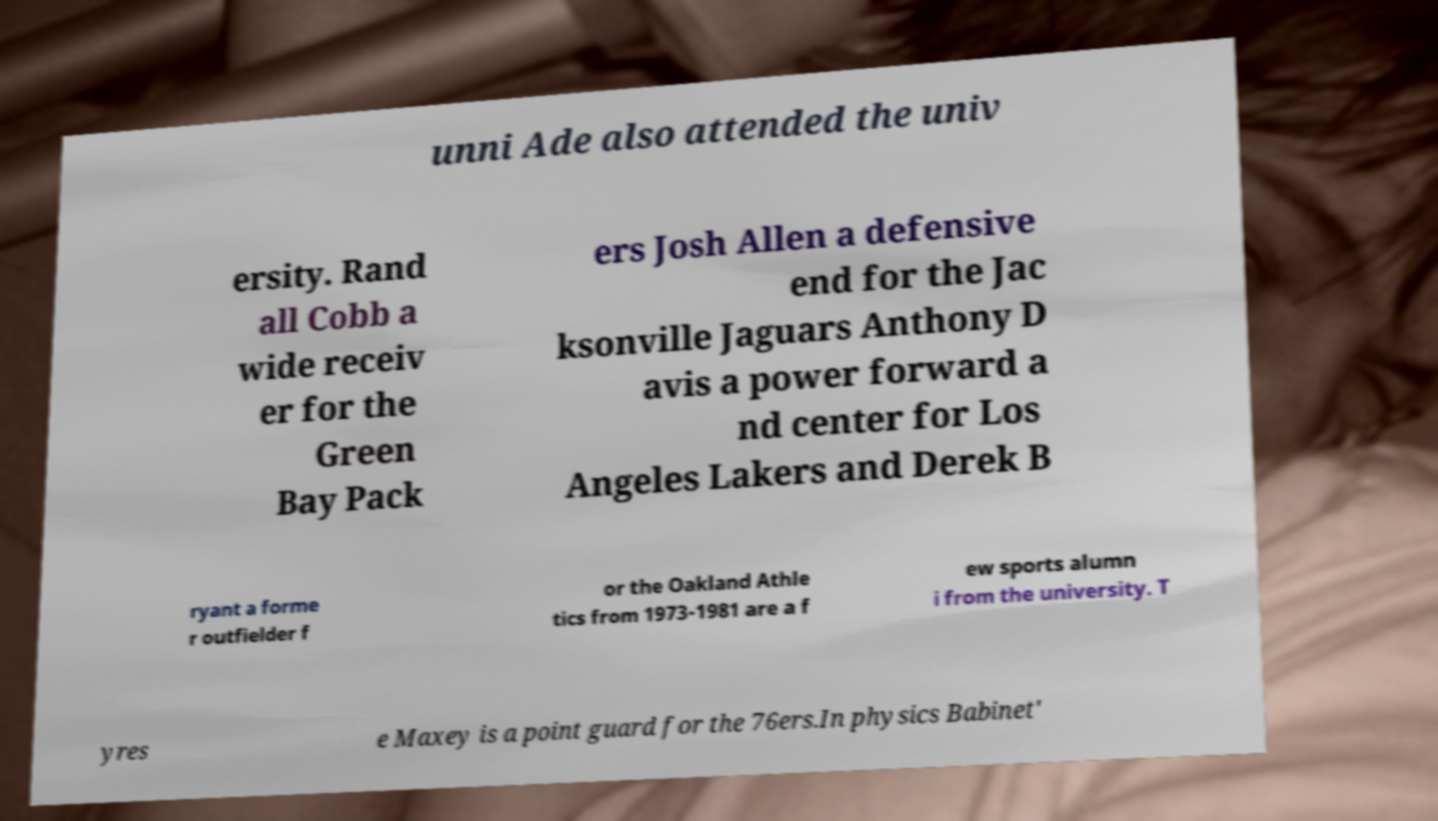There's text embedded in this image that I need extracted. Can you transcribe it verbatim? unni Ade also attended the univ ersity. Rand all Cobb a wide receiv er for the Green Bay Pack ers Josh Allen a defensive end for the Jac ksonville Jaguars Anthony D avis a power forward a nd center for Los Angeles Lakers and Derek B ryant a forme r outfielder f or the Oakland Athle tics from 1973-1981 are a f ew sports alumn i from the university. T yres e Maxey is a point guard for the 76ers.In physics Babinet' 